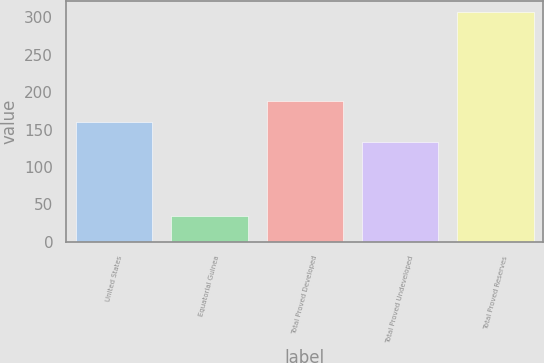Convert chart to OTSL. <chart><loc_0><loc_0><loc_500><loc_500><bar_chart><fcel>United States<fcel>Equatorial Guinea<fcel>Total Proved Developed<fcel>Total Proved Undeveloped<fcel>Total Proved Reserves<nl><fcel>160.3<fcel>34<fcel>187.6<fcel>133<fcel>307<nl></chart> 